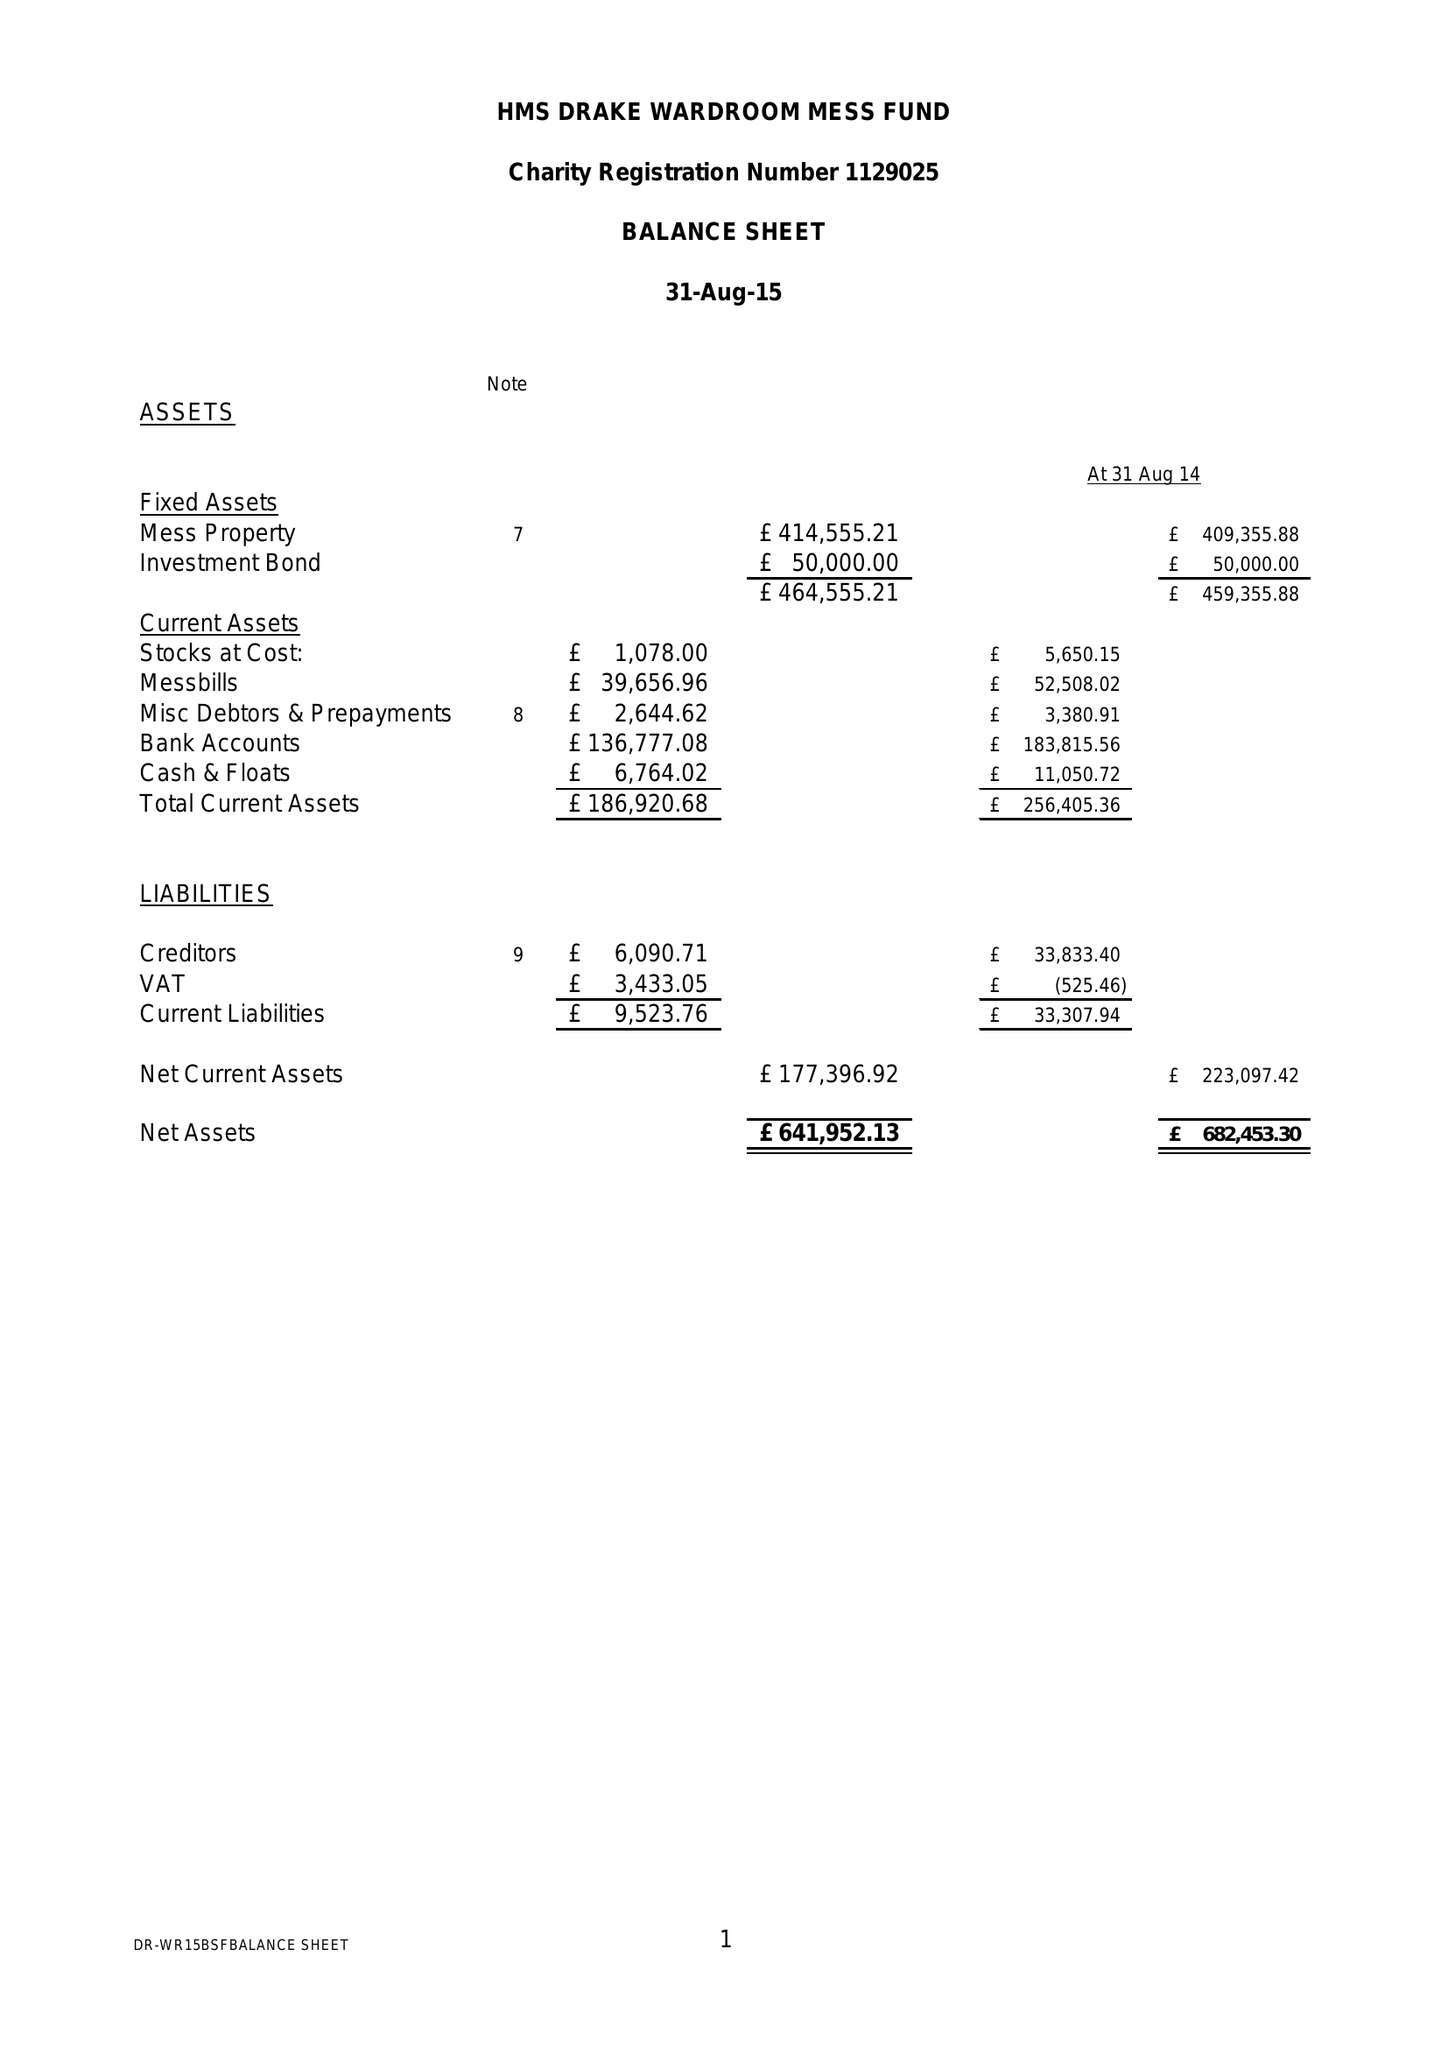What is the value for the charity_name?
Answer the question using a single word or phrase. The Wardroom Mess, Hms Drake 